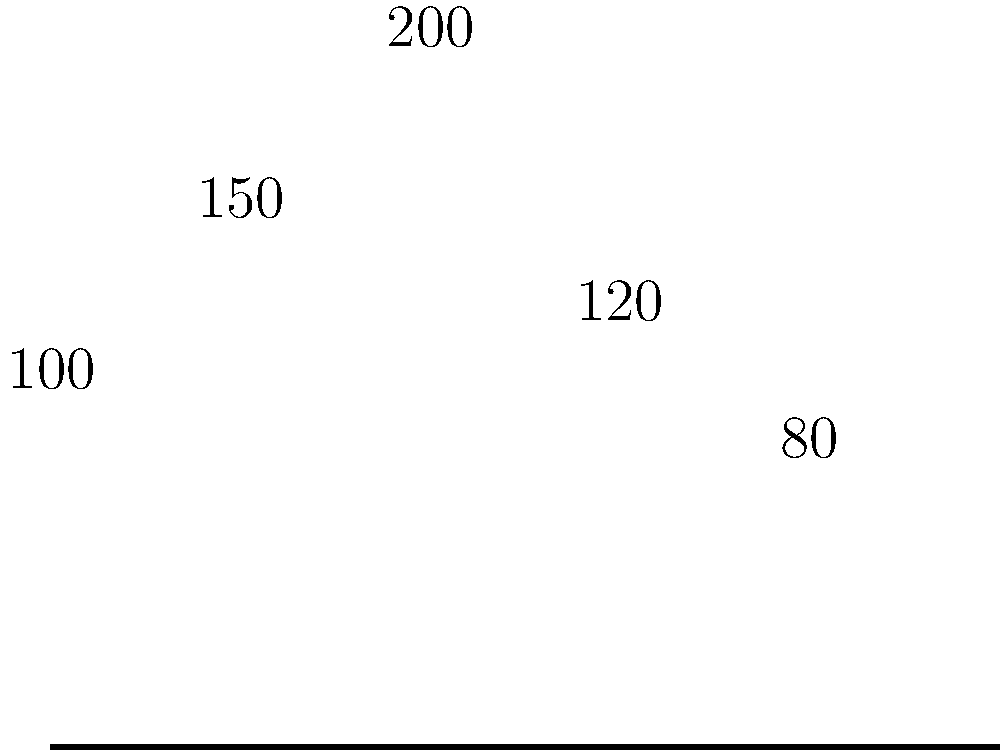Based on the bar graph showing inventory levels for different sizes of fitness apparel, which size should be prioritized for restocking to maintain optimal inventory levels, and why? To determine which size should be prioritized for restocking, we need to analyze the inventory levels for each size:

1. XS: 100 units
2. S: 150 units
3. M: 200 units
4. L: 120 units
5. XL: 80 units

The optimal inventory level should balance customer demand with storage costs. Generally, we want to maintain higher inventory for popular sizes and lower inventory for less common sizes.

Step 1: Identify the highest inventory level
The size with the highest inventory is M (200 units), suggesting it's likely the most popular size.

Step 2: Compare other sizes to the highest level
- S (150 units) and L (120 units) have relatively high inventory levels, indicating they're also popular sizes.
- XS (100 units) has a moderate inventory level.
- XL (80 units) has the lowest inventory level.

Step 3: Determine the size to prioritize for restocking
XL has the lowest inventory level, which could indicate:
a) It's the least popular size, or
b) It's currently understocked and needs replenishment.

As an entrepreneur running a women's fitness apparel brand, you should investigate the sales data for XL sizes. If the low inventory is due to high demand and quick sellouts, then XL should be prioritized for restocking to avoid potential lost sales.

Step 4: Consider the business impact
Restocking XL sizes could:
- Increase sales if there's unmet demand
- Improve customer satisfaction by ensuring product availability
- Optimize inventory balance across all sizes

Therefore, based on the given information, XL should be prioritized for restocking to maintain optimal inventory levels across all sizes.
Answer: XL size, due to lowest current inventory level 